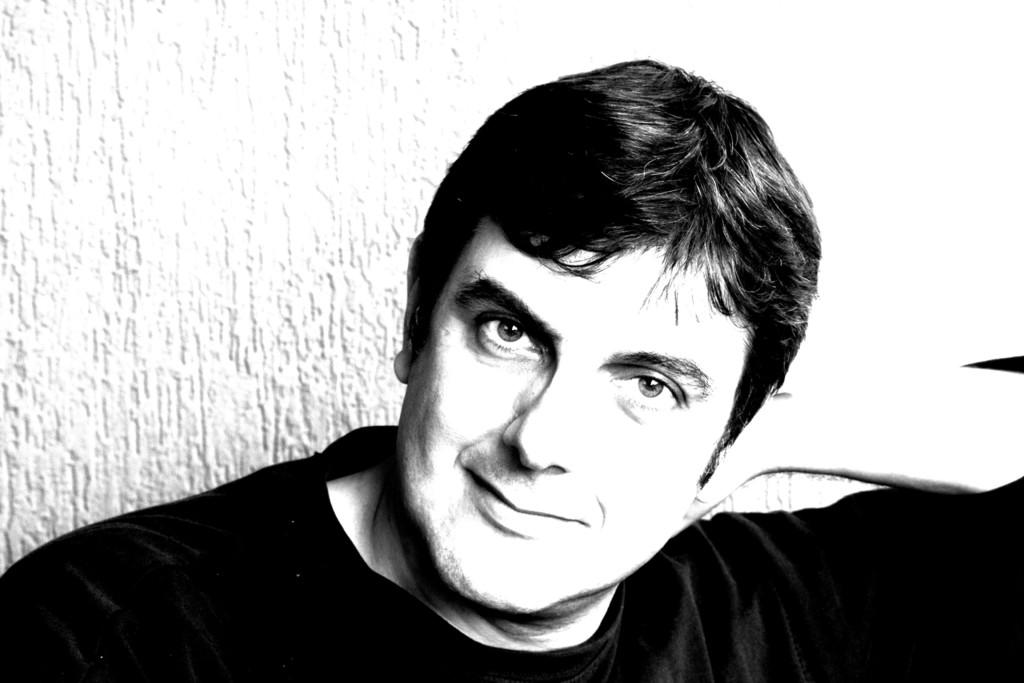What is the color scheme of the image? The image is black and white. What is the main subject of the picture? There is an image of a man in the picture. What type of stove is visible in the image? There is no stove present in the image. How does the man say good-bye in the image? The image does not depict any action or interaction, so it is not possible to determine how the man says good-bye. 